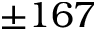Convert formula to latex. <formula><loc_0><loc_0><loc_500><loc_500>\pm 1 6 7</formula> 